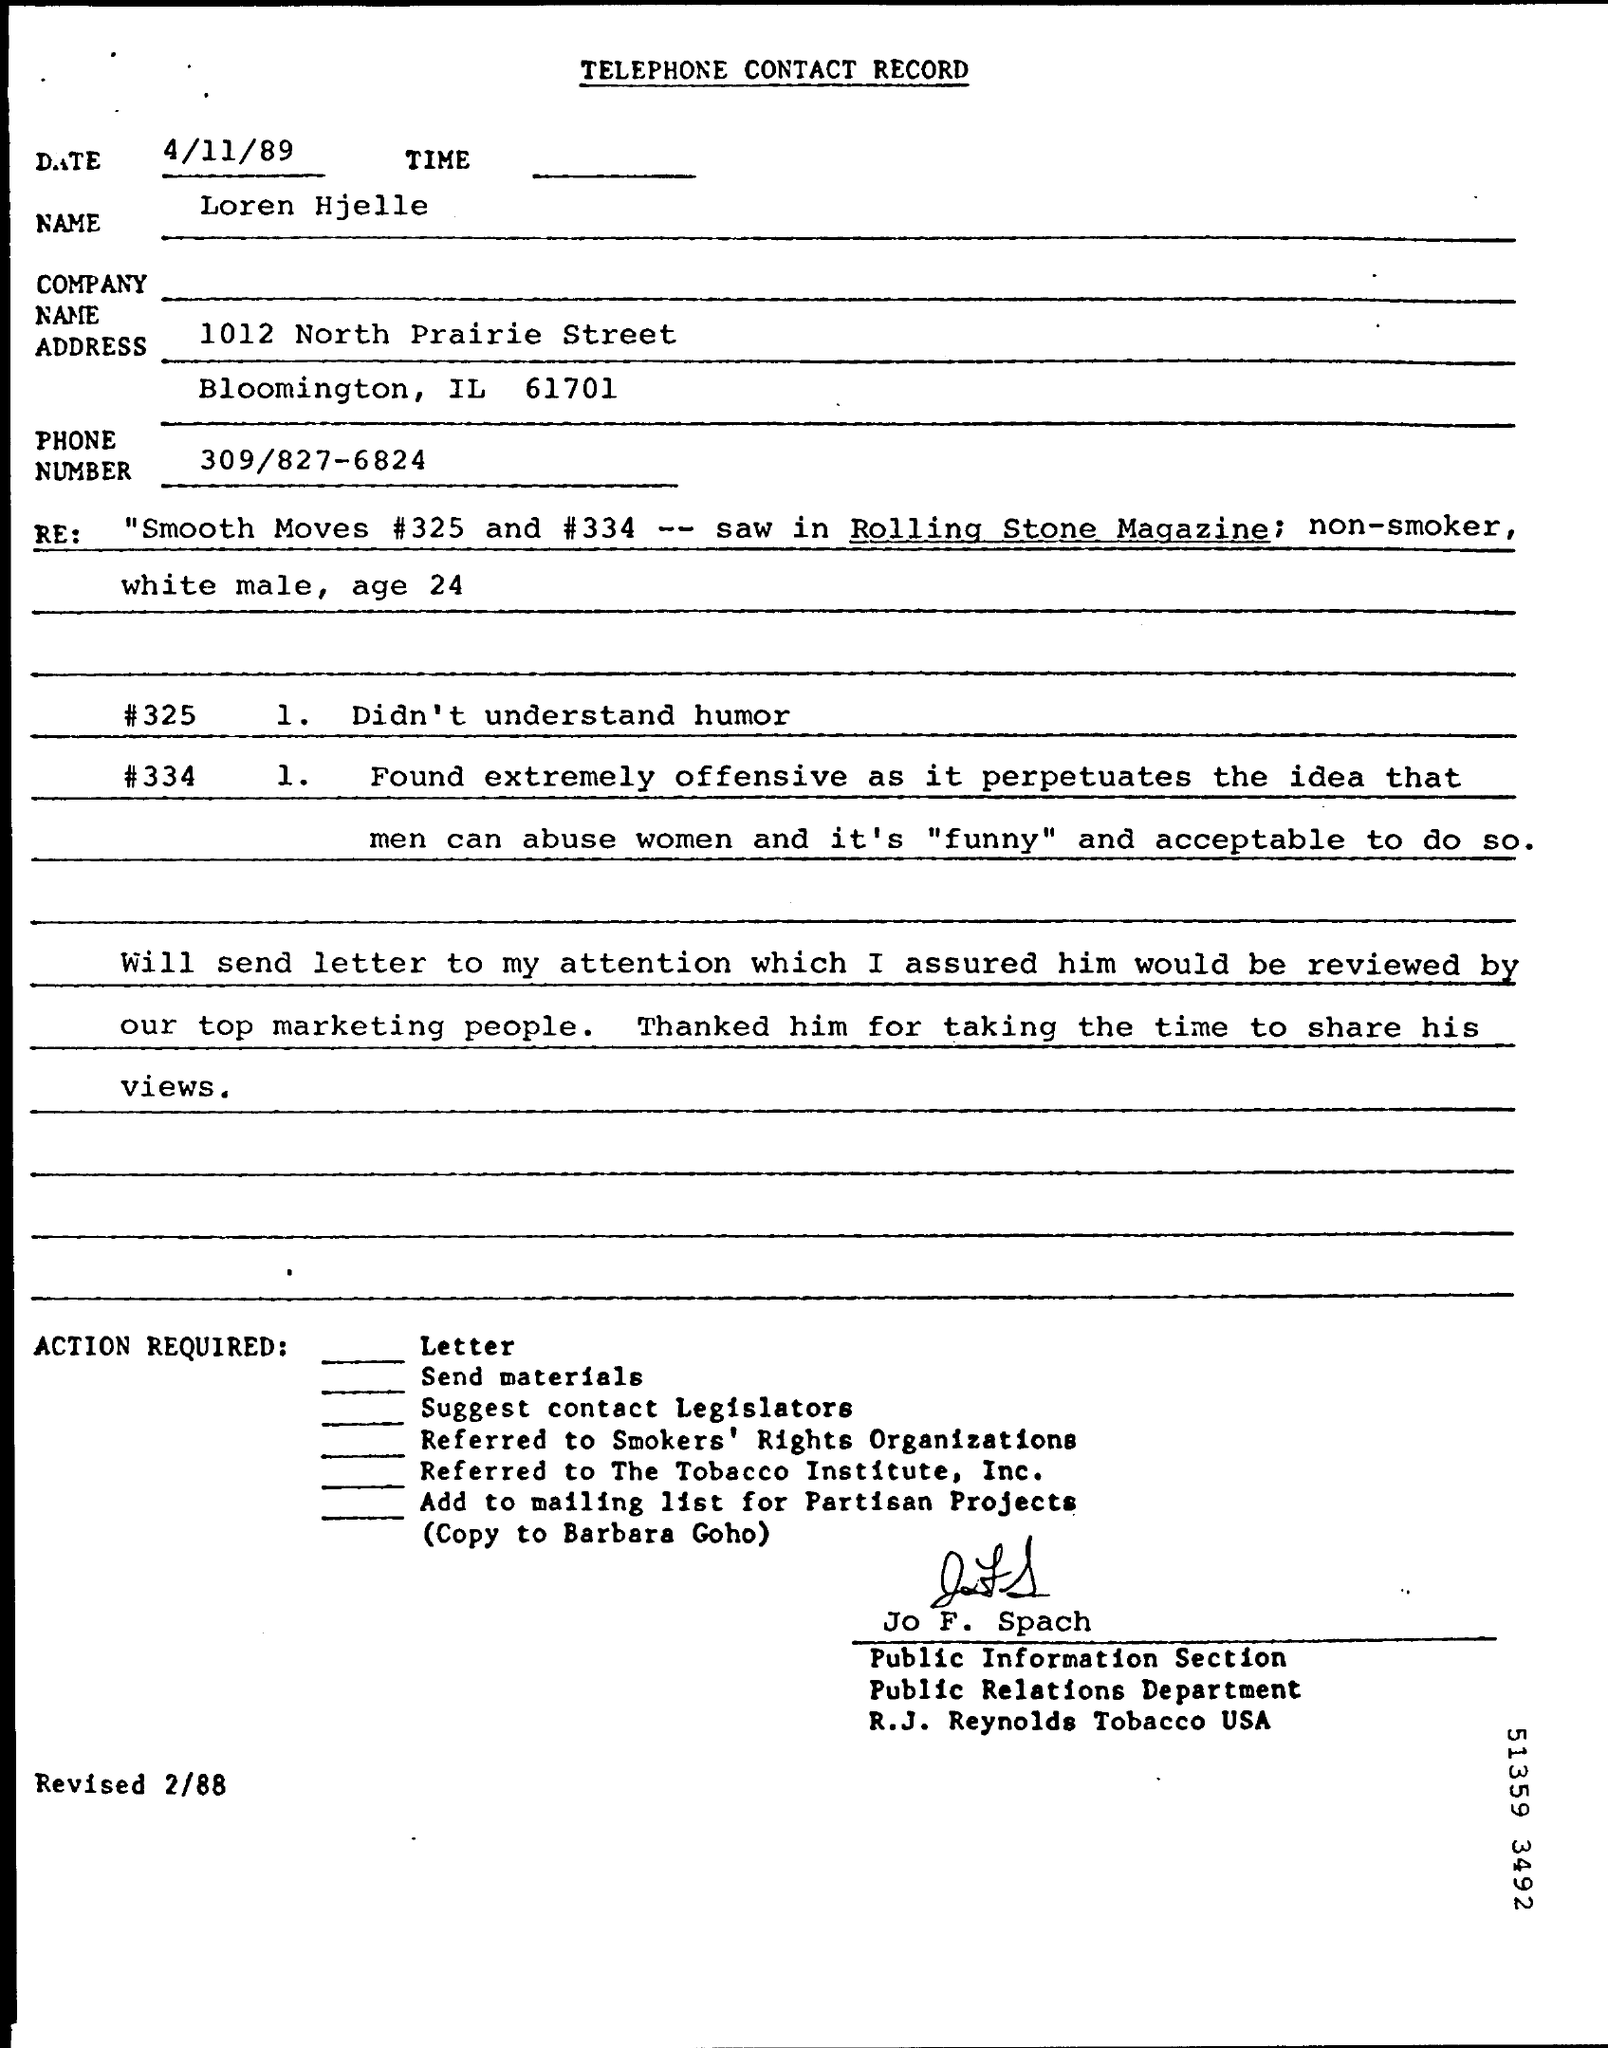List a handful of essential elements in this visual. The date mentioned is 4/11/89. The address provided is located in the state of Illinois and the city of Bloomington. Jo F. Spach is a member of the Public Relations Department. The phone number mentioned is 309/827-6824. The Public Relations Department is a specific department named. 